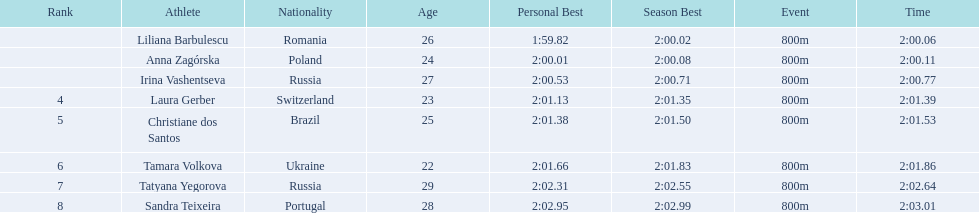What was the time difference between the first place finisher and the eighth place finisher? 2.95. Can you give me this table as a dict? {'header': ['Rank', 'Athlete', 'Nationality', 'Age', 'Personal Best', 'Season Best', 'Event', 'Time'], 'rows': [['', 'Liliana Barbulescu', 'Romania', '26', '1:59.82', '2:00.02', '800m', '2:00.06'], ['', 'Anna Zagórska', 'Poland', '24', '2:00.01', '2:00.08', '800m', '2:00.11'], ['', 'Irina Vashentseva', 'Russia', '27', '2:00.53', '2:00.71', '800m', '2:00.77'], ['4', 'Laura Gerber', 'Switzerland', '23', '2:01.13', '2:01.35', '800m', '2:01.39'], ['5', 'Christiane dos Santos', 'Brazil', '25', '2:01.38', '2:01.50', '800m', '2:01.53'], ['6', 'Tamara Volkova', 'Ukraine', '22', '2:01.66', '2:01.83', '800m', '2:01.86'], ['7', 'Tatyana Yegorova', 'Russia', '29', '2:02.31', '2:02.55', '800m', '2:02.64'], ['8', 'Sandra Teixeira', 'Portugal', '28', '2:02.95', '2:02.99', '800m', '2:03.01']]} 